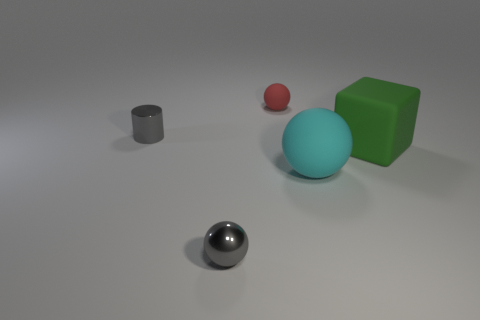What number of other things are there of the same material as the gray cylinder
Offer a terse response. 1. There is a metal thing behind the rubber sphere in front of the metallic cylinder; are there any green cubes that are to the left of it?
Make the answer very short. No. Does the gray cylinder have the same material as the large cyan object?
Keep it short and to the point. No. Is there anything else that is the same shape as the large cyan rubber object?
Provide a short and direct response. Yes. There is a tiny sphere that is on the right side of the sphere left of the tiny red rubber thing; what is its material?
Keep it short and to the point. Rubber. There is a gray metal thing that is on the left side of the gray metallic sphere; what size is it?
Your answer should be compact. Small. There is a rubber thing that is left of the green block and behind the big rubber ball; what color is it?
Your answer should be very brief. Red. There is a metal thing in front of the gray cylinder; is its size the same as the cyan sphere?
Provide a succinct answer. No. There is a rubber sphere that is behind the metal cylinder; are there any small gray metal cylinders that are left of it?
Offer a very short reply. Yes. What material is the tiny red object?
Offer a very short reply. Rubber. 